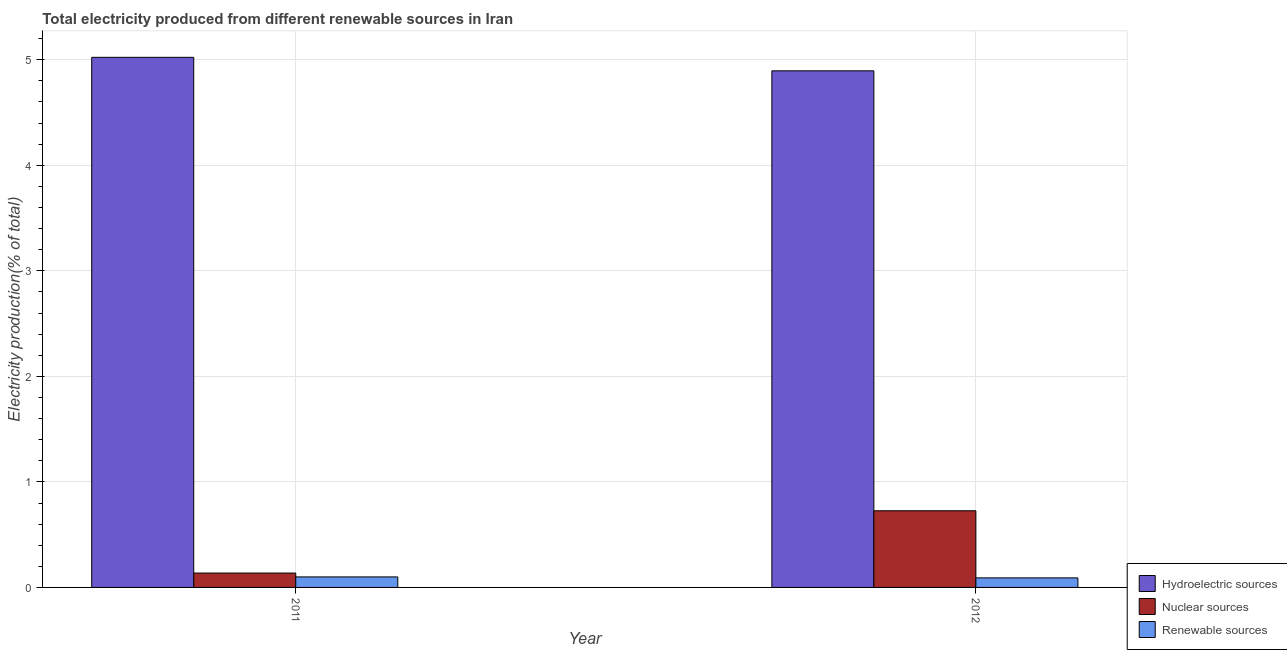How many different coloured bars are there?
Offer a terse response. 3. Are the number of bars on each tick of the X-axis equal?
Your response must be concise. Yes. What is the label of the 1st group of bars from the left?
Your response must be concise. 2011. In how many cases, is the number of bars for a given year not equal to the number of legend labels?
Provide a short and direct response. 0. What is the percentage of electricity produced by hydroelectric sources in 2011?
Give a very brief answer. 5.02. Across all years, what is the maximum percentage of electricity produced by nuclear sources?
Your answer should be compact. 0.73. Across all years, what is the minimum percentage of electricity produced by renewable sources?
Give a very brief answer. 0.09. In which year was the percentage of electricity produced by hydroelectric sources maximum?
Your answer should be very brief. 2011. In which year was the percentage of electricity produced by nuclear sources minimum?
Provide a succinct answer. 2011. What is the total percentage of electricity produced by hydroelectric sources in the graph?
Your response must be concise. 9.92. What is the difference between the percentage of electricity produced by hydroelectric sources in 2011 and that in 2012?
Provide a short and direct response. 0.13. What is the difference between the percentage of electricity produced by nuclear sources in 2011 and the percentage of electricity produced by renewable sources in 2012?
Make the answer very short. -0.59. What is the average percentage of electricity produced by nuclear sources per year?
Offer a terse response. 0.43. In how many years, is the percentage of electricity produced by hydroelectric sources greater than 4.8 %?
Make the answer very short. 2. What is the ratio of the percentage of electricity produced by nuclear sources in 2011 to that in 2012?
Ensure brevity in your answer.  0.19. What does the 3rd bar from the left in 2011 represents?
Offer a very short reply. Renewable sources. What does the 3rd bar from the right in 2011 represents?
Your answer should be very brief. Hydroelectric sources. Is it the case that in every year, the sum of the percentage of electricity produced by hydroelectric sources and percentage of electricity produced by nuclear sources is greater than the percentage of electricity produced by renewable sources?
Provide a short and direct response. Yes. How many bars are there?
Offer a very short reply. 6. What is the difference between two consecutive major ticks on the Y-axis?
Offer a very short reply. 1. How are the legend labels stacked?
Your answer should be very brief. Vertical. What is the title of the graph?
Offer a terse response. Total electricity produced from different renewable sources in Iran. What is the label or title of the X-axis?
Ensure brevity in your answer.  Year. What is the label or title of the Y-axis?
Offer a terse response. Electricity production(% of total). What is the Electricity production(% of total) of Hydroelectric sources in 2011?
Provide a succinct answer. 5.02. What is the Electricity production(% of total) in Nuclear sources in 2011?
Ensure brevity in your answer.  0.14. What is the Electricity production(% of total) of Renewable sources in 2011?
Your response must be concise. 0.1. What is the Electricity production(% of total) in Hydroelectric sources in 2012?
Make the answer very short. 4.9. What is the Electricity production(% of total) of Nuclear sources in 2012?
Provide a short and direct response. 0.73. What is the Electricity production(% of total) of Renewable sources in 2012?
Your response must be concise. 0.09. Across all years, what is the maximum Electricity production(% of total) of Hydroelectric sources?
Make the answer very short. 5.02. Across all years, what is the maximum Electricity production(% of total) in Nuclear sources?
Your answer should be very brief. 0.73. Across all years, what is the maximum Electricity production(% of total) in Renewable sources?
Keep it short and to the point. 0.1. Across all years, what is the minimum Electricity production(% of total) in Hydroelectric sources?
Give a very brief answer. 4.9. Across all years, what is the minimum Electricity production(% of total) in Nuclear sources?
Your answer should be compact. 0.14. Across all years, what is the minimum Electricity production(% of total) in Renewable sources?
Offer a very short reply. 0.09. What is the total Electricity production(% of total) in Hydroelectric sources in the graph?
Your answer should be very brief. 9.92. What is the total Electricity production(% of total) of Nuclear sources in the graph?
Your answer should be very brief. 0.86. What is the total Electricity production(% of total) of Renewable sources in the graph?
Ensure brevity in your answer.  0.19. What is the difference between the Electricity production(% of total) of Hydroelectric sources in 2011 and that in 2012?
Offer a very short reply. 0.13. What is the difference between the Electricity production(% of total) of Nuclear sources in 2011 and that in 2012?
Your answer should be compact. -0.59. What is the difference between the Electricity production(% of total) in Renewable sources in 2011 and that in 2012?
Provide a succinct answer. 0.01. What is the difference between the Electricity production(% of total) in Hydroelectric sources in 2011 and the Electricity production(% of total) in Nuclear sources in 2012?
Your response must be concise. 4.3. What is the difference between the Electricity production(% of total) of Hydroelectric sources in 2011 and the Electricity production(% of total) of Renewable sources in 2012?
Ensure brevity in your answer.  4.93. What is the difference between the Electricity production(% of total) of Nuclear sources in 2011 and the Electricity production(% of total) of Renewable sources in 2012?
Make the answer very short. 0.05. What is the average Electricity production(% of total) of Hydroelectric sources per year?
Keep it short and to the point. 4.96. What is the average Electricity production(% of total) of Nuclear sources per year?
Provide a short and direct response. 0.43. What is the average Electricity production(% of total) of Renewable sources per year?
Provide a succinct answer. 0.1. In the year 2011, what is the difference between the Electricity production(% of total) in Hydroelectric sources and Electricity production(% of total) in Nuclear sources?
Your answer should be compact. 4.89. In the year 2011, what is the difference between the Electricity production(% of total) of Hydroelectric sources and Electricity production(% of total) of Renewable sources?
Give a very brief answer. 4.92. In the year 2011, what is the difference between the Electricity production(% of total) of Nuclear sources and Electricity production(% of total) of Renewable sources?
Your answer should be very brief. 0.04. In the year 2012, what is the difference between the Electricity production(% of total) in Hydroelectric sources and Electricity production(% of total) in Nuclear sources?
Ensure brevity in your answer.  4.17. In the year 2012, what is the difference between the Electricity production(% of total) in Hydroelectric sources and Electricity production(% of total) in Renewable sources?
Give a very brief answer. 4.8. In the year 2012, what is the difference between the Electricity production(% of total) of Nuclear sources and Electricity production(% of total) of Renewable sources?
Your response must be concise. 0.64. What is the ratio of the Electricity production(% of total) of Hydroelectric sources in 2011 to that in 2012?
Offer a very short reply. 1.03. What is the ratio of the Electricity production(% of total) of Nuclear sources in 2011 to that in 2012?
Ensure brevity in your answer.  0.19. What is the ratio of the Electricity production(% of total) of Renewable sources in 2011 to that in 2012?
Ensure brevity in your answer.  1.1. What is the difference between the highest and the second highest Electricity production(% of total) of Hydroelectric sources?
Keep it short and to the point. 0.13. What is the difference between the highest and the second highest Electricity production(% of total) in Nuclear sources?
Provide a short and direct response. 0.59. What is the difference between the highest and the second highest Electricity production(% of total) in Renewable sources?
Your answer should be compact. 0.01. What is the difference between the highest and the lowest Electricity production(% of total) in Hydroelectric sources?
Your response must be concise. 0.13. What is the difference between the highest and the lowest Electricity production(% of total) of Nuclear sources?
Give a very brief answer. 0.59. What is the difference between the highest and the lowest Electricity production(% of total) in Renewable sources?
Ensure brevity in your answer.  0.01. 